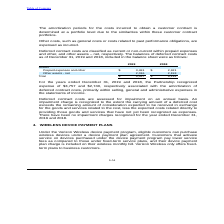According to Consolidated Communications Holdings's financial document, What was the expense recognized by the Partnership in 2019?  According to the financial document, $3,757. The relevant text states: "9 and 2018 , the Partnership recognized expense of $3,757 and $2,740, respectively associated with the amortization of deferred contract costs, primarily with..." Also, What is the Prepaid expenses and other for 2019? According to the financial document, $ 3,481. The relevant text states: "Prepaid expenses and other $ 3,481 $ 2,921..." Also, How often are Deferred contract costs are assessed for impairment? According to the financial document, on an annual basis. The relevant text states: "ferred contract costs are assessed for impairment on an annual basis. An impairment charge is recognized to the extent the carrying amount of a deferred cost exceeds th..." Also, can you calculate: What was the increase / (decrease) in the prepaid expenses and other assets from 2018 to 2019? Based on the calculation: 3,481 - 2,921, the result is 560. This is based on the information: "Prepaid expenses and other $ 3,481 $ 2,921 Prepaid expenses and other $ 3,481 $ 2,921..." The key data points involved are: 2,921, 3,481. Also, can you calculate: What was the average other assets-net for 2018 and 2019? To answer this question, I need to perform calculations using the financial data. The calculation is: (2,016 + 2,193) / 2, which equals 2104.5. This is based on the information: "Other assets - net 2,016 2,193 Other assets - net 2,016 2,193..." The key data points involved are: 2,016, 2,193. Also, can you calculate: What was the percentage increase / (decrease) in the total assets from 2018 to 2019? To answer this question, I need to perform calculations using the financial data. The calculation is: 5,497 / 5,114 - 1, which equals 7.49 (percentage). This is based on the information: "Total $ 5,497 $ 5,114 Total $ 5,497 $ 5,114..." The key data points involved are: 5,114, 5,497. 